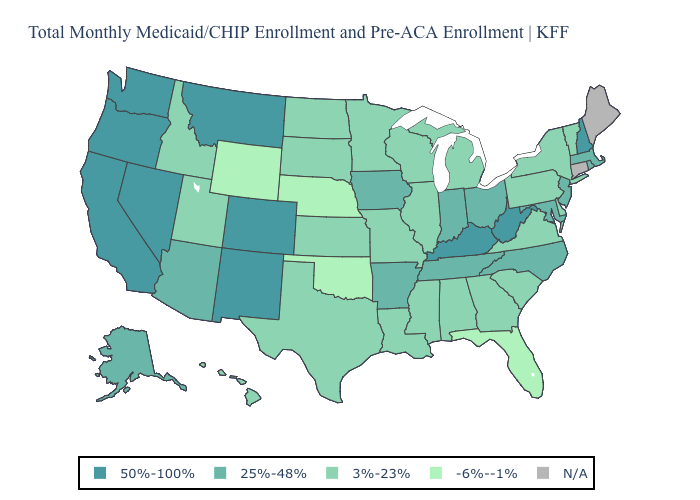Is the legend a continuous bar?
Be succinct. No. Which states hav the highest value in the MidWest?
Give a very brief answer. Indiana, Iowa, Ohio. Does the first symbol in the legend represent the smallest category?
Write a very short answer. No. Name the states that have a value in the range 25%-48%?
Quick response, please. Alaska, Arizona, Arkansas, Indiana, Iowa, Maryland, Massachusetts, New Jersey, North Carolina, Ohio, Rhode Island, Tennessee. Does Nebraska have the lowest value in the MidWest?
Keep it brief. Yes. What is the highest value in states that border West Virginia?
Give a very brief answer. 50%-100%. Name the states that have a value in the range -6%--1%?
Write a very short answer. Florida, Nebraska, Oklahoma, Wyoming. Does the first symbol in the legend represent the smallest category?
Short answer required. No. Which states have the lowest value in the South?
Concise answer only. Florida, Oklahoma. Name the states that have a value in the range 50%-100%?
Write a very short answer. California, Colorado, Kentucky, Montana, Nevada, New Hampshire, New Mexico, Oregon, Washington, West Virginia. How many symbols are there in the legend?
Give a very brief answer. 5. Name the states that have a value in the range N/A?
Quick response, please. Connecticut, Maine. What is the value of Virginia?
Quick response, please. 3%-23%. What is the value of Wisconsin?
Keep it brief. 3%-23%. What is the value of Colorado?
Concise answer only. 50%-100%. 